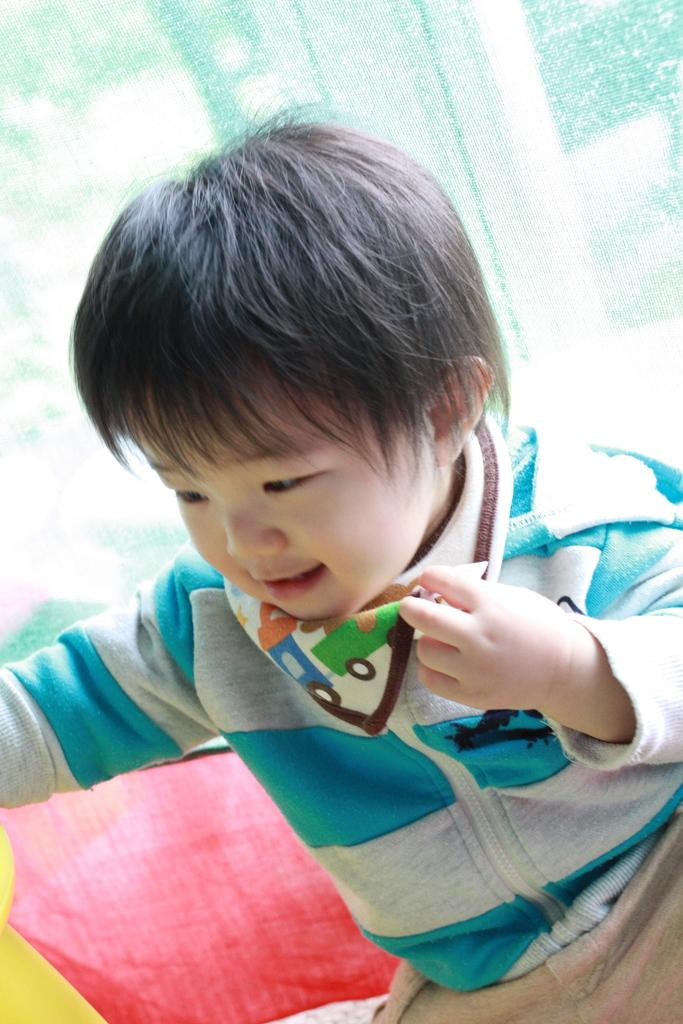What is the main subject of the image? The main subject of the image is a kid. What is the kid wearing in the image? The kid is wearing a coat in the image. What is the kid holding in the image? The kid is holding an object in the image. Can you describe anything visible in the background of the image? There is a cloth visible in the background of the image. How many tomatoes can be seen growing in the image? There are no tomatoes visible in the image. What type of clover is present in the image? There is no clover present in the image. 